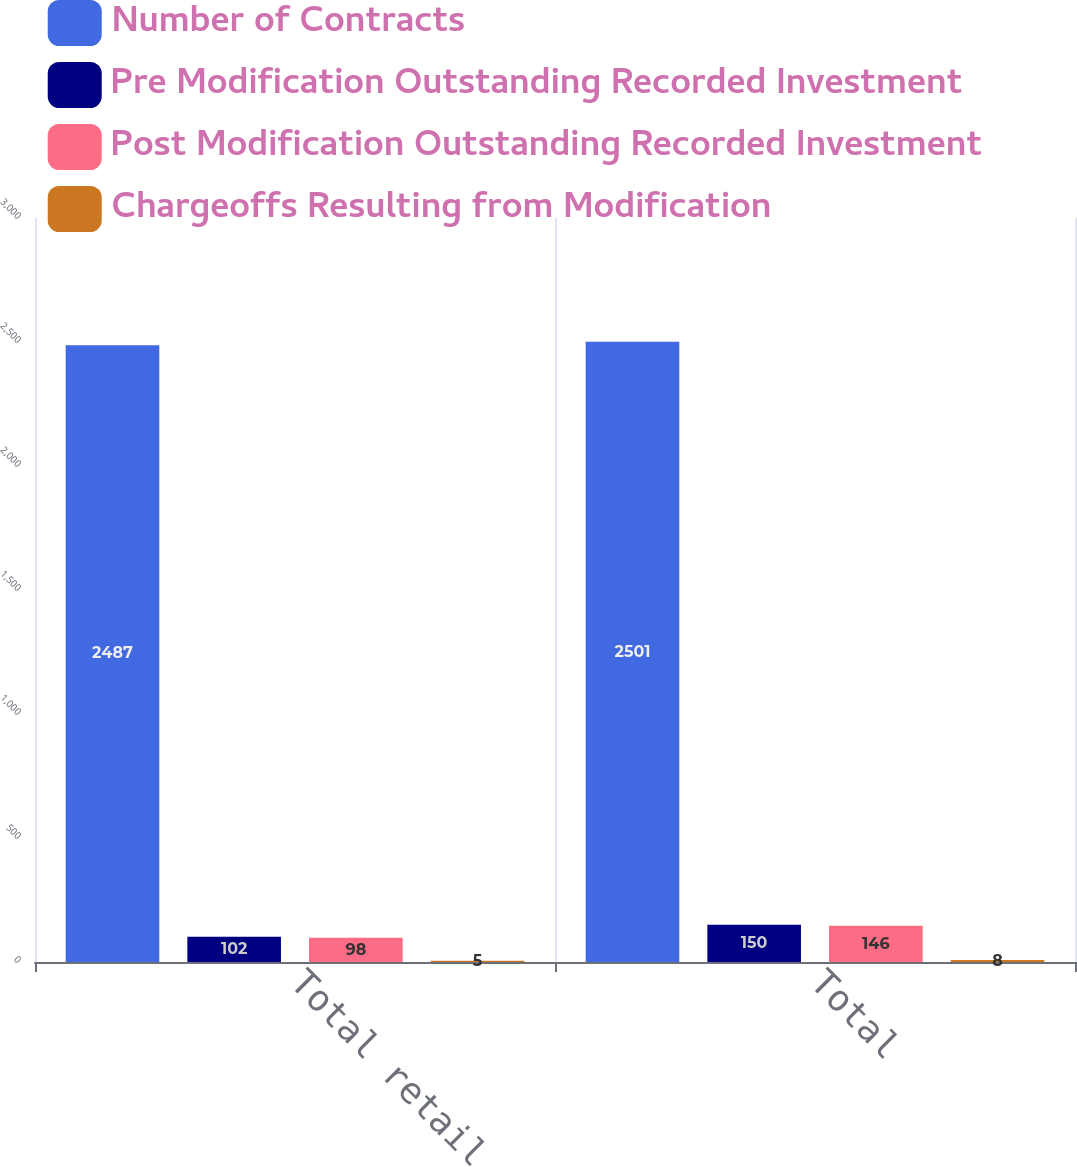Convert chart to OTSL. <chart><loc_0><loc_0><loc_500><loc_500><stacked_bar_chart><ecel><fcel>Total retail<fcel>Total<nl><fcel>Number of Contracts<fcel>2487<fcel>2501<nl><fcel>Pre Modification Outstanding Recorded Investment<fcel>102<fcel>150<nl><fcel>Post Modification Outstanding Recorded Investment<fcel>98<fcel>146<nl><fcel>Chargeoffs Resulting from Modification<fcel>5<fcel>8<nl></chart> 